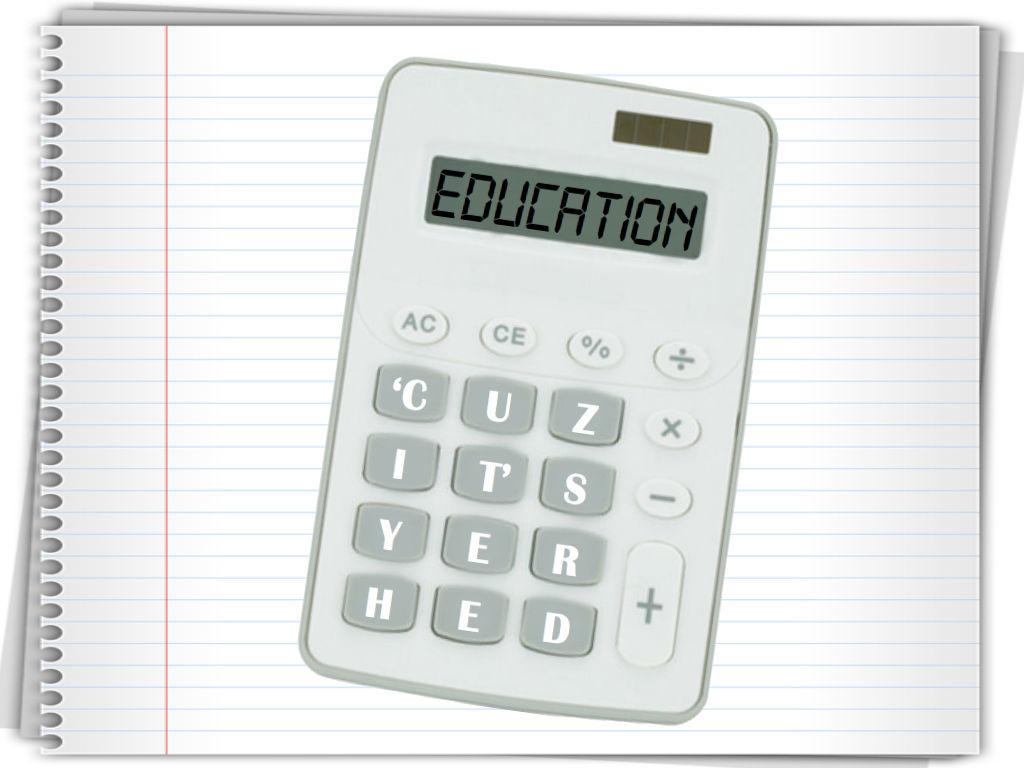<image>
Create a compact narrative representing the image presented. A small grade calculator has the word education in its read out window. 